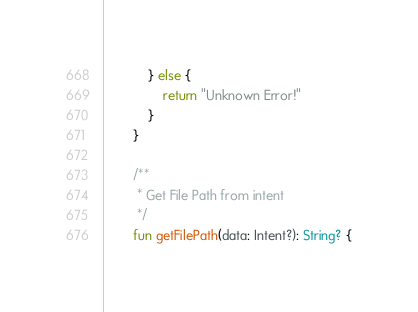<code> <loc_0><loc_0><loc_500><loc_500><_Kotlin_>            } else {
                return "Unknown Error!"
            }
        }

        /**
         * Get File Path from intent
         */
        fun getFilePath(data: Intent?): String? {</code> 